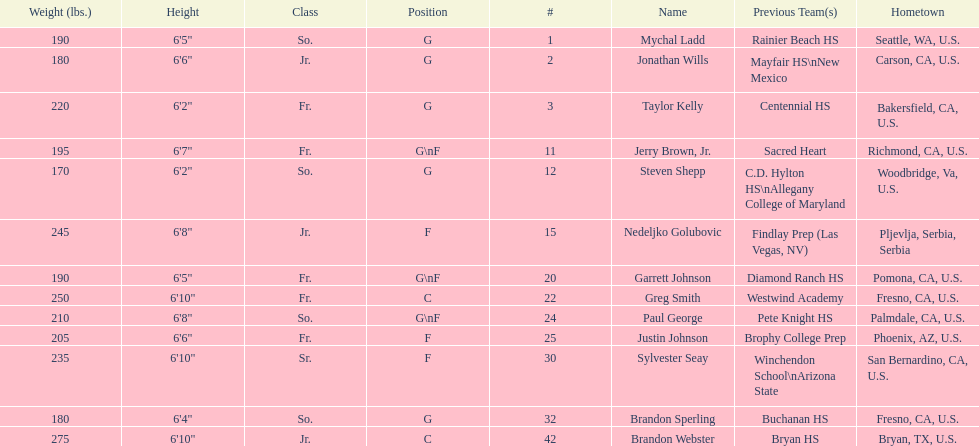Which player previously played for sacred heart? Jerry Brown, Jr. 